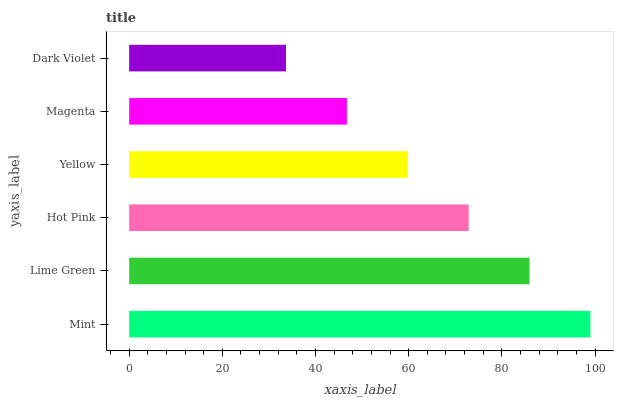Is Dark Violet the minimum?
Answer yes or no. Yes. Is Mint the maximum?
Answer yes or no. Yes. Is Lime Green the minimum?
Answer yes or no. No. Is Lime Green the maximum?
Answer yes or no. No. Is Mint greater than Lime Green?
Answer yes or no. Yes. Is Lime Green less than Mint?
Answer yes or no. Yes. Is Lime Green greater than Mint?
Answer yes or no. No. Is Mint less than Lime Green?
Answer yes or no. No. Is Hot Pink the high median?
Answer yes or no. Yes. Is Yellow the low median?
Answer yes or no. Yes. Is Dark Violet the high median?
Answer yes or no. No. Is Mint the low median?
Answer yes or no. No. 